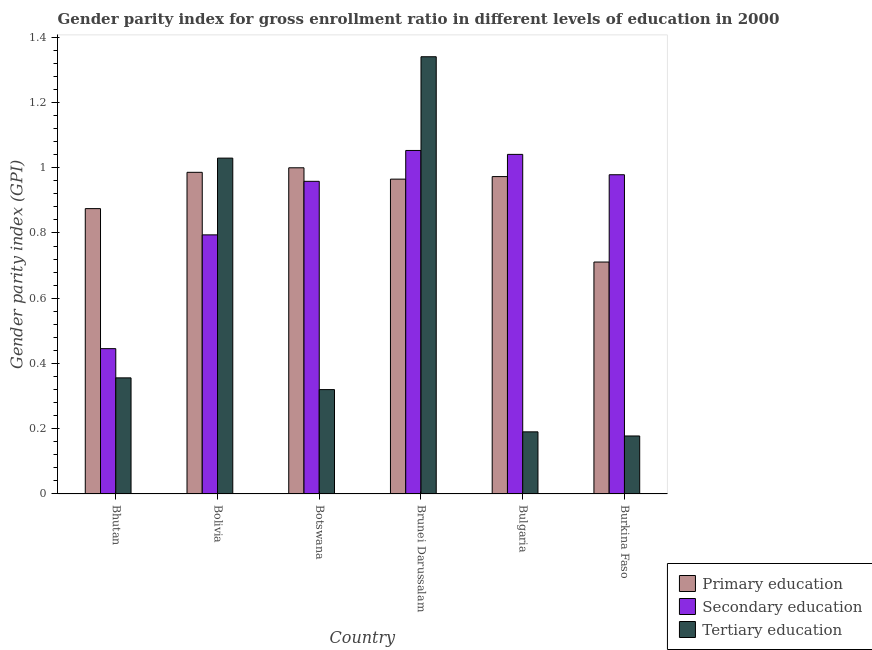How many different coloured bars are there?
Make the answer very short. 3. How many groups of bars are there?
Keep it short and to the point. 6. Are the number of bars on each tick of the X-axis equal?
Offer a very short reply. Yes. How many bars are there on the 1st tick from the right?
Your answer should be compact. 3. What is the label of the 4th group of bars from the left?
Provide a succinct answer. Brunei Darussalam. In how many cases, is the number of bars for a given country not equal to the number of legend labels?
Provide a succinct answer. 0. What is the gender parity index in primary education in Burkina Faso?
Provide a short and direct response. 0.71. Across all countries, what is the maximum gender parity index in secondary education?
Make the answer very short. 1.05. Across all countries, what is the minimum gender parity index in primary education?
Offer a terse response. 0.71. In which country was the gender parity index in secondary education maximum?
Give a very brief answer. Brunei Darussalam. In which country was the gender parity index in secondary education minimum?
Your response must be concise. Bhutan. What is the total gender parity index in secondary education in the graph?
Provide a short and direct response. 5.27. What is the difference between the gender parity index in tertiary education in Bolivia and that in Botswana?
Make the answer very short. 0.71. What is the difference between the gender parity index in primary education in Botswana and the gender parity index in tertiary education in Bhutan?
Give a very brief answer. 0.64. What is the average gender parity index in primary education per country?
Your answer should be compact. 0.92. What is the difference between the gender parity index in primary education and gender parity index in tertiary education in Brunei Darussalam?
Give a very brief answer. -0.38. In how many countries, is the gender parity index in secondary education greater than 1.36 ?
Ensure brevity in your answer.  0. What is the ratio of the gender parity index in tertiary education in Bolivia to that in Bulgaria?
Offer a very short reply. 5.41. Is the difference between the gender parity index in tertiary education in Bulgaria and Burkina Faso greater than the difference between the gender parity index in secondary education in Bulgaria and Burkina Faso?
Offer a terse response. No. What is the difference between the highest and the second highest gender parity index in primary education?
Provide a succinct answer. 0.01. What is the difference between the highest and the lowest gender parity index in tertiary education?
Provide a succinct answer. 1.16. In how many countries, is the gender parity index in secondary education greater than the average gender parity index in secondary education taken over all countries?
Provide a short and direct response. 4. Is the sum of the gender parity index in tertiary education in Bolivia and Bulgaria greater than the maximum gender parity index in primary education across all countries?
Provide a succinct answer. Yes. Is it the case that in every country, the sum of the gender parity index in primary education and gender parity index in secondary education is greater than the gender parity index in tertiary education?
Offer a terse response. Yes. How many bars are there?
Offer a very short reply. 18. Does the graph contain grids?
Keep it short and to the point. No. How many legend labels are there?
Your answer should be very brief. 3. How are the legend labels stacked?
Offer a terse response. Vertical. What is the title of the graph?
Your answer should be very brief. Gender parity index for gross enrollment ratio in different levels of education in 2000. What is the label or title of the X-axis?
Ensure brevity in your answer.  Country. What is the label or title of the Y-axis?
Provide a short and direct response. Gender parity index (GPI). What is the Gender parity index (GPI) of Primary education in Bhutan?
Provide a short and direct response. 0.87. What is the Gender parity index (GPI) in Secondary education in Bhutan?
Offer a terse response. 0.45. What is the Gender parity index (GPI) in Tertiary education in Bhutan?
Your answer should be very brief. 0.36. What is the Gender parity index (GPI) in Primary education in Bolivia?
Ensure brevity in your answer.  0.99. What is the Gender parity index (GPI) of Secondary education in Bolivia?
Your response must be concise. 0.79. What is the Gender parity index (GPI) of Tertiary education in Bolivia?
Offer a terse response. 1.03. What is the Gender parity index (GPI) of Primary education in Botswana?
Your answer should be very brief. 1. What is the Gender parity index (GPI) in Secondary education in Botswana?
Your answer should be compact. 0.96. What is the Gender parity index (GPI) of Tertiary education in Botswana?
Your response must be concise. 0.32. What is the Gender parity index (GPI) in Primary education in Brunei Darussalam?
Your answer should be compact. 0.97. What is the Gender parity index (GPI) of Secondary education in Brunei Darussalam?
Offer a very short reply. 1.05. What is the Gender parity index (GPI) in Tertiary education in Brunei Darussalam?
Your answer should be very brief. 1.34. What is the Gender parity index (GPI) in Primary education in Bulgaria?
Your answer should be compact. 0.97. What is the Gender parity index (GPI) in Secondary education in Bulgaria?
Give a very brief answer. 1.04. What is the Gender parity index (GPI) in Tertiary education in Bulgaria?
Offer a very short reply. 0.19. What is the Gender parity index (GPI) of Primary education in Burkina Faso?
Your response must be concise. 0.71. What is the Gender parity index (GPI) in Secondary education in Burkina Faso?
Provide a short and direct response. 0.98. What is the Gender parity index (GPI) of Tertiary education in Burkina Faso?
Offer a very short reply. 0.18. Across all countries, what is the maximum Gender parity index (GPI) of Primary education?
Ensure brevity in your answer.  1. Across all countries, what is the maximum Gender parity index (GPI) in Secondary education?
Provide a short and direct response. 1.05. Across all countries, what is the maximum Gender parity index (GPI) in Tertiary education?
Your answer should be compact. 1.34. Across all countries, what is the minimum Gender parity index (GPI) in Primary education?
Offer a terse response. 0.71. Across all countries, what is the minimum Gender parity index (GPI) in Secondary education?
Provide a short and direct response. 0.45. Across all countries, what is the minimum Gender parity index (GPI) in Tertiary education?
Keep it short and to the point. 0.18. What is the total Gender parity index (GPI) in Primary education in the graph?
Offer a terse response. 5.51. What is the total Gender parity index (GPI) in Secondary education in the graph?
Offer a terse response. 5.27. What is the total Gender parity index (GPI) in Tertiary education in the graph?
Provide a succinct answer. 3.41. What is the difference between the Gender parity index (GPI) in Primary education in Bhutan and that in Bolivia?
Keep it short and to the point. -0.11. What is the difference between the Gender parity index (GPI) of Secondary education in Bhutan and that in Bolivia?
Provide a short and direct response. -0.35. What is the difference between the Gender parity index (GPI) in Tertiary education in Bhutan and that in Bolivia?
Keep it short and to the point. -0.67. What is the difference between the Gender parity index (GPI) of Primary education in Bhutan and that in Botswana?
Offer a terse response. -0.13. What is the difference between the Gender parity index (GPI) of Secondary education in Bhutan and that in Botswana?
Make the answer very short. -0.51. What is the difference between the Gender parity index (GPI) of Tertiary education in Bhutan and that in Botswana?
Your response must be concise. 0.04. What is the difference between the Gender parity index (GPI) in Primary education in Bhutan and that in Brunei Darussalam?
Offer a very short reply. -0.09. What is the difference between the Gender parity index (GPI) of Secondary education in Bhutan and that in Brunei Darussalam?
Ensure brevity in your answer.  -0.61. What is the difference between the Gender parity index (GPI) in Tertiary education in Bhutan and that in Brunei Darussalam?
Keep it short and to the point. -0.98. What is the difference between the Gender parity index (GPI) of Primary education in Bhutan and that in Bulgaria?
Offer a terse response. -0.1. What is the difference between the Gender parity index (GPI) of Secondary education in Bhutan and that in Bulgaria?
Provide a succinct answer. -0.6. What is the difference between the Gender parity index (GPI) in Tertiary education in Bhutan and that in Bulgaria?
Make the answer very short. 0.17. What is the difference between the Gender parity index (GPI) in Primary education in Bhutan and that in Burkina Faso?
Your answer should be very brief. 0.16. What is the difference between the Gender parity index (GPI) of Secondary education in Bhutan and that in Burkina Faso?
Your answer should be compact. -0.53. What is the difference between the Gender parity index (GPI) in Tertiary education in Bhutan and that in Burkina Faso?
Provide a succinct answer. 0.18. What is the difference between the Gender parity index (GPI) in Primary education in Bolivia and that in Botswana?
Give a very brief answer. -0.01. What is the difference between the Gender parity index (GPI) in Secondary education in Bolivia and that in Botswana?
Ensure brevity in your answer.  -0.16. What is the difference between the Gender parity index (GPI) of Tertiary education in Bolivia and that in Botswana?
Your answer should be very brief. 0.71. What is the difference between the Gender parity index (GPI) of Primary education in Bolivia and that in Brunei Darussalam?
Keep it short and to the point. 0.02. What is the difference between the Gender parity index (GPI) in Secondary education in Bolivia and that in Brunei Darussalam?
Your answer should be very brief. -0.26. What is the difference between the Gender parity index (GPI) in Tertiary education in Bolivia and that in Brunei Darussalam?
Offer a very short reply. -0.31. What is the difference between the Gender parity index (GPI) in Primary education in Bolivia and that in Bulgaria?
Your answer should be very brief. 0.01. What is the difference between the Gender parity index (GPI) of Secondary education in Bolivia and that in Bulgaria?
Give a very brief answer. -0.25. What is the difference between the Gender parity index (GPI) of Tertiary education in Bolivia and that in Bulgaria?
Give a very brief answer. 0.84. What is the difference between the Gender parity index (GPI) of Primary education in Bolivia and that in Burkina Faso?
Offer a terse response. 0.28. What is the difference between the Gender parity index (GPI) of Secondary education in Bolivia and that in Burkina Faso?
Your answer should be very brief. -0.18. What is the difference between the Gender parity index (GPI) of Tertiary education in Bolivia and that in Burkina Faso?
Provide a short and direct response. 0.85. What is the difference between the Gender parity index (GPI) in Primary education in Botswana and that in Brunei Darussalam?
Your answer should be very brief. 0.03. What is the difference between the Gender parity index (GPI) of Secondary education in Botswana and that in Brunei Darussalam?
Keep it short and to the point. -0.09. What is the difference between the Gender parity index (GPI) in Tertiary education in Botswana and that in Brunei Darussalam?
Your answer should be very brief. -1.02. What is the difference between the Gender parity index (GPI) in Primary education in Botswana and that in Bulgaria?
Your response must be concise. 0.03. What is the difference between the Gender parity index (GPI) of Secondary education in Botswana and that in Bulgaria?
Offer a terse response. -0.08. What is the difference between the Gender parity index (GPI) of Tertiary education in Botswana and that in Bulgaria?
Your answer should be very brief. 0.13. What is the difference between the Gender parity index (GPI) in Primary education in Botswana and that in Burkina Faso?
Keep it short and to the point. 0.29. What is the difference between the Gender parity index (GPI) in Secondary education in Botswana and that in Burkina Faso?
Offer a terse response. -0.02. What is the difference between the Gender parity index (GPI) in Tertiary education in Botswana and that in Burkina Faso?
Ensure brevity in your answer.  0.14. What is the difference between the Gender parity index (GPI) of Primary education in Brunei Darussalam and that in Bulgaria?
Offer a very short reply. -0.01. What is the difference between the Gender parity index (GPI) in Secondary education in Brunei Darussalam and that in Bulgaria?
Keep it short and to the point. 0.01. What is the difference between the Gender parity index (GPI) in Tertiary education in Brunei Darussalam and that in Bulgaria?
Give a very brief answer. 1.15. What is the difference between the Gender parity index (GPI) in Primary education in Brunei Darussalam and that in Burkina Faso?
Offer a terse response. 0.25. What is the difference between the Gender parity index (GPI) in Secondary education in Brunei Darussalam and that in Burkina Faso?
Offer a terse response. 0.07. What is the difference between the Gender parity index (GPI) of Tertiary education in Brunei Darussalam and that in Burkina Faso?
Offer a terse response. 1.16. What is the difference between the Gender parity index (GPI) in Primary education in Bulgaria and that in Burkina Faso?
Provide a short and direct response. 0.26. What is the difference between the Gender parity index (GPI) in Secondary education in Bulgaria and that in Burkina Faso?
Your answer should be compact. 0.06. What is the difference between the Gender parity index (GPI) in Tertiary education in Bulgaria and that in Burkina Faso?
Give a very brief answer. 0.01. What is the difference between the Gender parity index (GPI) in Primary education in Bhutan and the Gender parity index (GPI) in Secondary education in Bolivia?
Give a very brief answer. 0.08. What is the difference between the Gender parity index (GPI) of Primary education in Bhutan and the Gender parity index (GPI) of Tertiary education in Bolivia?
Your answer should be very brief. -0.15. What is the difference between the Gender parity index (GPI) in Secondary education in Bhutan and the Gender parity index (GPI) in Tertiary education in Bolivia?
Ensure brevity in your answer.  -0.58. What is the difference between the Gender parity index (GPI) in Primary education in Bhutan and the Gender parity index (GPI) in Secondary education in Botswana?
Provide a short and direct response. -0.08. What is the difference between the Gender parity index (GPI) of Primary education in Bhutan and the Gender parity index (GPI) of Tertiary education in Botswana?
Make the answer very short. 0.55. What is the difference between the Gender parity index (GPI) of Secondary education in Bhutan and the Gender parity index (GPI) of Tertiary education in Botswana?
Your answer should be very brief. 0.13. What is the difference between the Gender parity index (GPI) of Primary education in Bhutan and the Gender parity index (GPI) of Secondary education in Brunei Darussalam?
Offer a very short reply. -0.18. What is the difference between the Gender parity index (GPI) in Primary education in Bhutan and the Gender parity index (GPI) in Tertiary education in Brunei Darussalam?
Your answer should be compact. -0.47. What is the difference between the Gender parity index (GPI) in Secondary education in Bhutan and the Gender parity index (GPI) in Tertiary education in Brunei Darussalam?
Your answer should be compact. -0.89. What is the difference between the Gender parity index (GPI) of Primary education in Bhutan and the Gender parity index (GPI) of Secondary education in Bulgaria?
Ensure brevity in your answer.  -0.17. What is the difference between the Gender parity index (GPI) of Primary education in Bhutan and the Gender parity index (GPI) of Tertiary education in Bulgaria?
Give a very brief answer. 0.68. What is the difference between the Gender parity index (GPI) of Secondary education in Bhutan and the Gender parity index (GPI) of Tertiary education in Bulgaria?
Make the answer very short. 0.26. What is the difference between the Gender parity index (GPI) in Primary education in Bhutan and the Gender parity index (GPI) in Secondary education in Burkina Faso?
Give a very brief answer. -0.1. What is the difference between the Gender parity index (GPI) of Primary education in Bhutan and the Gender parity index (GPI) of Tertiary education in Burkina Faso?
Give a very brief answer. 0.7. What is the difference between the Gender parity index (GPI) of Secondary education in Bhutan and the Gender parity index (GPI) of Tertiary education in Burkina Faso?
Offer a terse response. 0.27. What is the difference between the Gender parity index (GPI) of Primary education in Bolivia and the Gender parity index (GPI) of Secondary education in Botswana?
Offer a very short reply. 0.03. What is the difference between the Gender parity index (GPI) in Primary education in Bolivia and the Gender parity index (GPI) in Tertiary education in Botswana?
Provide a short and direct response. 0.67. What is the difference between the Gender parity index (GPI) in Secondary education in Bolivia and the Gender parity index (GPI) in Tertiary education in Botswana?
Your response must be concise. 0.47. What is the difference between the Gender parity index (GPI) of Primary education in Bolivia and the Gender parity index (GPI) of Secondary education in Brunei Darussalam?
Offer a very short reply. -0.07. What is the difference between the Gender parity index (GPI) in Primary education in Bolivia and the Gender parity index (GPI) in Tertiary education in Brunei Darussalam?
Your answer should be very brief. -0.35. What is the difference between the Gender parity index (GPI) of Secondary education in Bolivia and the Gender parity index (GPI) of Tertiary education in Brunei Darussalam?
Your response must be concise. -0.55. What is the difference between the Gender parity index (GPI) of Primary education in Bolivia and the Gender parity index (GPI) of Secondary education in Bulgaria?
Your response must be concise. -0.06. What is the difference between the Gender parity index (GPI) in Primary education in Bolivia and the Gender parity index (GPI) in Tertiary education in Bulgaria?
Keep it short and to the point. 0.8. What is the difference between the Gender parity index (GPI) of Secondary education in Bolivia and the Gender parity index (GPI) of Tertiary education in Bulgaria?
Ensure brevity in your answer.  0.6. What is the difference between the Gender parity index (GPI) in Primary education in Bolivia and the Gender parity index (GPI) in Secondary education in Burkina Faso?
Keep it short and to the point. 0.01. What is the difference between the Gender parity index (GPI) in Primary education in Bolivia and the Gender parity index (GPI) in Tertiary education in Burkina Faso?
Your response must be concise. 0.81. What is the difference between the Gender parity index (GPI) of Secondary education in Bolivia and the Gender parity index (GPI) of Tertiary education in Burkina Faso?
Give a very brief answer. 0.62. What is the difference between the Gender parity index (GPI) in Primary education in Botswana and the Gender parity index (GPI) in Secondary education in Brunei Darussalam?
Provide a short and direct response. -0.05. What is the difference between the Gender parity index (GPI) of Primary education in Botswana and the Gender parity index (GPI) of Tertiary education in Brunei Darussalam?
Offer a terse response. -0.34. What is the difference between the Gender parity index (GPI) of Secondary education in Botswana and the Gender parity index (GPI) of Tertiary education in Brunei Darussalam?
Your response must be concise. -0.38. What is the difference between the Gender parity index (GPI) of Primary education in Botswana and the Gender parity index (GPI) of Secondary education in Bulgaria?
Provide a short and direct response. -0.04. What is the difference between the Gender parity index (GPI) of Primary education in Botswana and the Gender parity index (GPI) of Tertiary education in Bulgaria?
Make the answer very short. 0.81. What is the difference between the Gender parity index (GPI) of Secondary education in Botswana and the Gender parity index (GPI) of Tertiary education in Bulgaria?
Provide a succinct answer. 0.77. What is the difference between the Gender parity index (GPI) of Primary education in Botswana and the Gender parity index (GPI) of Secondary education in Burkina Faso?
Your answer should be compact. 0.02. What is the difference between the Gender parity index (GPI) in Primary education in Botswana and the Gender parity index (GPI) in Tertiary education in Burkina Faso?
Give a very brief answer. 0.82. What is the difference between the Gender parity index (GPI) of Secondary education in Botswana and the Gender parity index (GPI) of Tertiary education in Burkina Faso?
Provide a short and direct response. 0.78. What is the difference between the Gender parity index (GPI) in Primary education in Brunei Darussalam and the Gender parity index (GPI) in Secondary education in Bulgaria?
Your answer should be compact. -0.08. What is the difference between the Gender parity index (GPI) in Primary education in Brunei Darussalam and the Gender parity index (GPI) in Tertiary education in Bulgaria?
Offer a very short reply. 0.77. What is the difference between the Gender parity index (GPI) of Secondary education in Brunei Darussalam and the Gender parity index (GPI) of Tertiary education in Bulgaria?
Your answer should be compact. 0.86. What is the difference between the Gender parity index (GPI) in Primary education in Brunei Darussalam and the Gender parity index (GPI) in Secondary education in Burkina Faso?
Your response must be concise. -0.01. What is the difference between the Gender parity index (GPI) in Primary education in Brunei Darussalam and the Gender parity index (GPI) in Tertiary education in Burkina Faso?
Your answer should be very brief. 0.79. What is the difference between the Gender parity index (GPI) in Secondary education in Brunei Darussalam and the Gender parity index (GPI) in Tertiary education in Burkina Faso?
Ensure brevity in your answer.  0.88. What is the difference between the Gender parity index (GPI) of Primary education in Bulgaria and the Gender parity index (GPI) of Secondary education in Burkina Faso?
Give a very brief answer. -0.01. What is the difference between the Gender parity index (GPI) in Primary education in Bulgaria and the Gender parity index (GPI) in Tertiary education in Burkina Faso?
Offer a very short reply. 0.8. What is the difference between the Gender parity index (GPI) of Secondary education in Bulgaria and the Gender parity index (GPI) of Tertiary education in Burkina Faso?
Offer a terse response. 0.86. What is the average Gender parity index (GPI) of Primary education per country?
Offer a terse response. 0.92. What is the average Gender parity index (GPI) in Secondary education per country?
Make the answer very short. 0.88. What is the average Gender parity index (GPI) of Tertiary education per country?
Give a very brief answer. 0.57. What is the difference between the Gender parity index (GPI) of Primary education and Gender parity index (GPI) of Secondary education in Bhutan?
Give a very brief answer. 0.43. What is the difference between the Gender parity index (GPI) of Primary education and Gender parity index (GPI) of Tertiary education in Bhutan?
Your response must be concise. 0.52. What is the difference between the Gender parity index (GPI) of Secondary education and Gender parity index (GPI) of Tertiary education in Bhutan?
Your answer should be very brief. 0.09. What is the difference between the Gender parity index (GPI) of Primary education and Gender parity index (GPI) of Secondary education in Bolivia?
Offer a terse response. 0.19. What is the difference between the Gender parity index (GPI) in Primary education and Gender parity index (GPI) in Tertiary education in Bolivia?
Provide a succinct answer. -0.04. What is the difference between the Gender parity index (GPI) of Secondary education and Gender parity index (GPI) of Tertiary education in Bolivia?
Keep it short and to the point. -0.24. What is the difference between the Gender parity index (GPI) of Primary education and Gender parity index (GPI) of Secondary education in Botswana?
Your response must be concise. 0.04. What is the difference between the Gender parity index (GPI) in Primary education and Gender parity index (GPI) in Tertiary education in Botswana?
Offer a terse response. 0.68. What is the difference between the Gender parity index (GPI) of Secondary education and Gender parity index (GPI) of Tertiary education in Botswana?
Provide a short and direct response. 0.64. What is the difference between the Gender parity index (GPI) in Primary education and Gender parity index (GPI) in Secondary education in Brunei Darussalam?
Your answer should be very brief. -0.09. What is the difference between the Gender parity index (GPI) in Primary education and Gender parity index (GPI) in Tertiary education in Brunei Darussalam?
Provide a short and direct response. -0.38. What is the difference between the Gender parity index (GPI) of Secondary education and Gender parity index (GPI) of Tertiary education in Brunei Darussalam?
Offer a terse response. -0.29. What is the difference between the Gender parity index (GPI) of Primary education and Gender parity index (GPI) of Secondary education in Bulgaria?
Give a very brief answer. -0.07. What is the difference between the Gender parity index (GPI) in Primary education and Gender parity index (GPI) in Tertiary education in Bulgaria?
Offer a terse response. 0.78. What is the difference between the Gender parity index (GPI) of Secondary education and Gender parity index (GPI) of Tertiary education in Bulgaria?
Offer a terse response. 0.85. What is the difference between the Gender parity index (GPI) in Primary education and Gender parity index (GPI) in Secondary education in Burkina Faso?
Ensure brevity in your answer.  -0.27. What is the difference between the Gender parity index (GPI) in Primary education and Gender parity index (GPI) in Tertiary education in Burkina Faso?
Keep it short and to the point. 0.53. What is the difference between the Gender parity index (GPI) of Secondary education and Gender parity index (GPI) of Tertiary education in Burkina Faso?
Offer a terse response. 0.8. What is the ratio of the Gender parity index (GPI) of Primary education in Bhutan to that in Bolivia?
Provide a succinct answer. 0.89. What is the ratio of the Gender parity index (GPI) in Secondary education in Bhutan to that in Bolivia?
Provide a short and direct response. 0.56. What is the ratio of the Gender parity index (GPI) in Tertiary education in Bhutan to that in Bolivia?
Provide a succinct answer. 0.35. What is the ratio of the Gender parity index (GPI) in Primary education in Bhutan to that in Botswana?
Offer a very short reply. 0.87. What is the ratio of the Gender parity index (GPI) of Secondary education in Bhutan to that in Botswana?
Your response must be concise. 0.46. What is the ratio of the Gender parity index (GPI) of Tertiary education in Bhutan to that in Botswana?
Offer a terse response. 1.11. What is the ratio of the Gender parity index (GPI) in Primary education in Bhutan to that in Brunei Darussalam?
Offer a terse response. 0.91. What is the ratio of the Gender parity index (GPI) of Secondary education in Bhutan to that in Brunei Darussalam?
Your response must be concise. 0.42. What is the ratio of the Gender parity index (GPI) in Tertiary education in Bhutan to that in Brunei Darussalam?
Ensure brevity in your answer.  0.27. What is the ratio of the Gender parity index (GPI) in Primary education in Bhutan to that in Bulgaria?
Offer a terse response. 0.9. What is the ratio of the Gender parity index (GPI) of Secondary education in Bhutan to that in Bulgaria?
Provide a short and direct response. 0.43. What is the ratio of the Gender parity index (GPI) in Tertiary education in Bhutan to that in Bulgaria?
Provide a succinct answer. 1.87. What is the ratio of the Gender parity index (GPI) in Primary education in Bhutan to that in Burkina Faso?
Your answer should be very brief. 1.23. What is the ratio of the Gender parity index (GPI) of Secondary education in Bhutan to that in Burkina Faso?
Provide a short and direct response. 0.46. What is the ratio of the Gender parity index (GPI) in Tertiary education in Bhutan to that in Burkina Faso?
Provide a succinct answer. 2. What is the ratio of the Gender parity index (GPI) in Primary education in Bolivia to that in Botswana?
Your response must be concise. 0.99. What is the ratio of the Gender parity index (GPI) in Secondary education in Bolivia to that in Botswana?
Give a very brief answer. 0.83. What is the ratio of the Gender parity index (GPI) of Tertiary education in Bolivia to that in Botswana?
Keep it short and to the point. 3.22. What is the ratio of the Gender parity index (GPI) in Primary education in Bolivia to that in Brunei Darussalam?
Give a very brief answer. 1.02. What is the ratio of the Gender parity index (GPI) of Secondary education in Bolivia to that in Brunei Darussalam?
Ensure brevity in your answer.  0.75. What is the ratio of the Gender parity index (GPI) in Tertiary education in Bolivia to that in Brunei Darussalam?
Make the answer very short. 0.77. What is the ratio of the Gender parity index (GPI) in Primary education in Bolivia to that in Bulgaria?
Provide a short and direct response. 1.01. What is the ratio of the Gender parity index (GPI) of Secondary education in Bolivia to that in Bulgaria?
Give a very brief answer. 0.76. What is the ratio of the Gender parity index (GPI) of Tertiary education in Bolivia to that in Bulgaria?
Your response must be concise. 5.41. What is the ratio of the Gender parity index (GPI) in Primary education in Bolivia to that in Burkina Faso?
Your answer should be very brief. 1.39. What is the ratio of the Gender parity index (GPI) in Secondary education in Bolivia to that in Burkina Faso?
Offer a terse response. 0.81. What is the ratio of the Gender parity index (GPI) in Tertiary education in Bolivia to that in Burkina Faso?
Offer a very short reply. 5.79. What is the ratio of the Gender parity index (GPI) in Primary education in Botswana to that in Brunei Darussalam?
Your answer should be very brief. 1.04. What is the ratio of the Gender parity index (GPI) in Secondary education in Botswana to that in Brunei Darussalam?
Offer a very short reply. 0.91. What is the ratio of the Gender parity index (GPI) in Tertiary education in Botswana to that in Brunei Darussalam?
Ensure brevity in your answer.  0.24. What is the ratio of the Gender parity index (GPI) of Primary education in Botswana to that in Bulgaria?
Your answer should be very brief. 1.03. What is the ratio of the Gender parity index (GPI) of Secondary education in Botswana to that in Bulgaria?
Provide a succinct answer. 0.92. What is the ratio of the Gender parity index (GPI) of Tertiary education in Botswana to that in Bulgaria?
Offer a terse response. 1.68. What is the ratio of the Gender parity index (GPI) of Primary education in Botswana to that in Burkina Faso?
Your response must be concise. 1.41. What is the ratio of the Gender parity index (GPI) of Secondary education in Botswana to that in Burkina Faso?
Offer a terse response. 0.98. What is the ratio of the Gender parity index (GPI) in Tertiary education in Botswana to that in Burkina Faso?
Provide a short and direct response. 1.8. What is the ratio of the Gender parity index (GPI) in Secondary education in Brunei Darussalam to that in Bulgaria?
Your response must be concise. 1.01. What is the ratio of the Gender parity index (GPI) of Tertiary education in Brunei Darussalam to that in Bulgaria?
Provide a succinct answer. 7.04. What is the ratio of the Gender parity index (GPI) of Primary education in Brunei Darussalam to that in Burkina Faso?
Keep it short and to the point. 1.36. What is the ratio of the Gender parity index (GPI) in Secondary education in Brunei Darussalam to that in Burkina Faso?
Your answer should be very brief. 1.08. What is the ratio of the Gender parity index (GPI) of Tertiary education in Brunei Darussalam to that in Burkina Faso?
Keep it short and to the point. 7.54. What is the ratio of the Gender parity index (GPI) of Primary education in Bulgaria to that in Burkina Faso?
Ensure brevity in your answer.  1.37. What is the ratio of the Gender parity index (GPI) in Secondary education in Bulgaria to that in Burkina Faso?
Give a very brief answer. 1.06. What is the ratio of the Gender parity index (GPI) in Tertiary education in Bulgaria to that in Burkina Faso?
Provide a short and direct response. 1.07. What is the difference between the highest and the second highest Gender parity index (GPI) of Primary education?
Your answer should be compact. 0.01. What is the difference between the highest and the second highest Gender parity index (GPI) of Secondary education?
Make the answer very short. 0.01. What is the difference between the highest and the second highest Gender parity index (GPI) in Tertiary education?
Make the answer very short. 0.31. What is the difference between the highest and the lowest Gender parity index (GPI) of Primary education?
Your answer should be very brief. 0.29. What is the difference between the highest and the lowest Gender parity index (GPI) of Secondary education?
Offer a very short reply. 0.61. What is the difference between the highest and the lowest Gender parity index (GPI) of Tertiary education?
Keep it short and to the point. 1.16. 